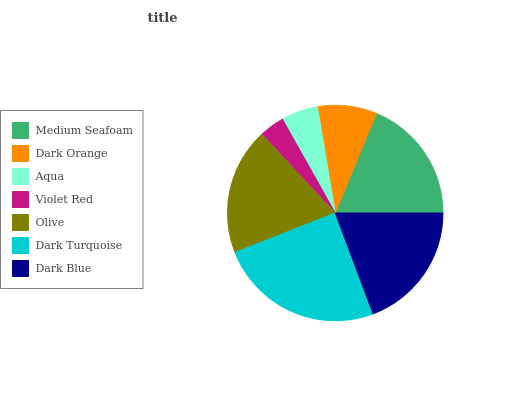Is Violet Red the minimum?
Answer yes or no. Yes. Is Dark Turquoise the maximum?
Answer yes or no. Yes. Is Dark Orange the minimum?
Answer yes or no. No. Is Dark Orange the maximum?
Answer yes or no. No. Is Medium Seafoam greater than Dark Orange?
Answer yes or no. Yes. Is Dark Orange less than Medium Seafoam?
Answer yes or no. Yes. Is Dark Orange greater than Medium Seafoam?
Answer yes or no. No. Is Medium Seafoam less than Dark Orange?
Answer yes or no. No. Is Medium Seafoam the high median?
Answer yes or no. Yes. Is Medium Seafoam the low median?
Answer yes or no. Yes. Is Dark Orange the high median?
Answer yes or no. No. Is Dark Turquoise the low median?
Answer yes or no. No. 